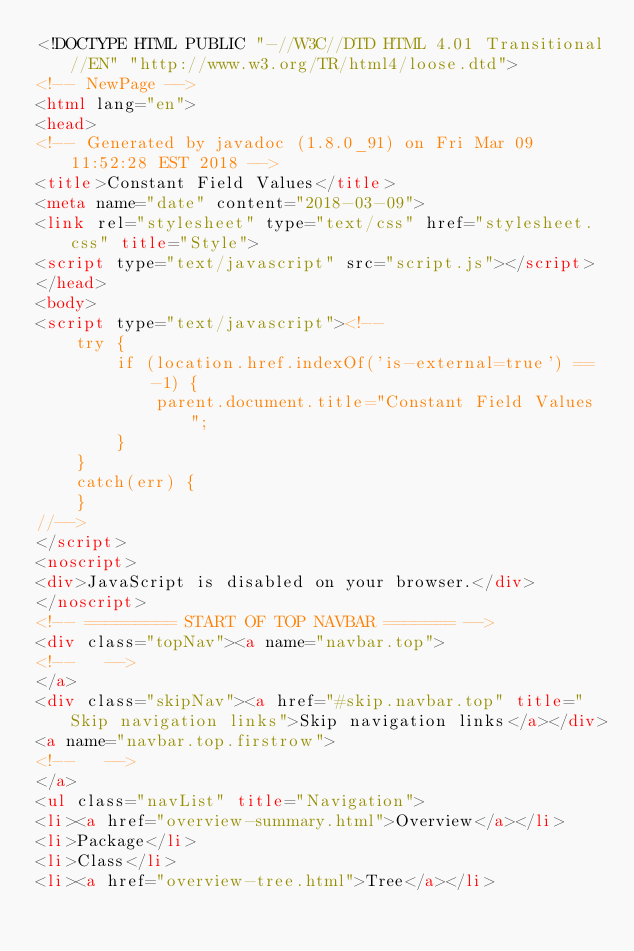<code> <loc_0><loc_0><loc_500><loc_500><_HTML_><!DOCTYPE HTML PUBLIC "-//W3C//DTD HTML 4.01 Transitional//EN" "http://www.w3.org/TR/html4/loose.dtd">
<!-- NewPage -->
<html lang="en">
<head>
<!-- Generated by javadoc (1.8.0_91) on Fri Mar 09 11:52:28 EST 2018 -->
<title>Constant Field Values</title>
<meta name="date" content="2018-03-09">
<link rel="stylesheet" type="text/css" href="stylesheet.css" title="Style">
<script type="text/javascript" src="script.js"></script>
</head>
<body>
<script type="text/javascript"><!--
    try {
        if (location.href.indexOf('is-external=true') == -1) {
            parent.document.title="Constant Field Values";
        }
    }
    catch(err) {
    }
//-->
</script>
<noscript>
<div>JavaScript is disabled on your browser.</div>
</noscript>
<!-- ========= START OF TOP NAVBAR ======= -->
<div class="topNav"><a name="navbar.top">
<!--   -->
</a>
<div class="skipNav"><a href="#skip.navbar.top" title="Skip navigation links">Skip navigation links</a></div>
<a name="navbar.top.firstrow">
<!--   -->
</a>
<ul class="navList" title="Navigation">
<li><a href="overview-summary.html">Overview</a></li>
<li>Package</li>
<li>Class</li>
<li><a href="overview-tree.html">Tree</a></li></code> 